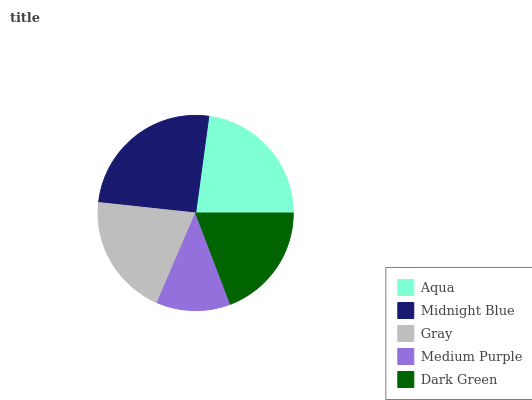Is Medium Purple the minimum?
Answer yes or no. Yes. Is Midnight Blue the maximum?
Answer yes or no. Yes. Is Gray the minimum?
Answer yes or no. No. Is Gray the maximum?
Answer yes or no. No. Is Midnight Blue greater than Gray?
Answer yes or no. Yes. Is Gray less than Midnight Blue?
Answer yes or no. Yes. Is Gray greater than Midnight Blue?
Answer yes or no. No. Is Midnight Blue less than Gray?
Answer yes or no. No. Is Gray the high median?
Answer yes or no. Yes. Is Gray the low median?
Answer yes or no. Yes. Is Dark Green the high median?
Answer yes or no. No. Is Midnight Blue the low median?
Answer yes or no. No. 